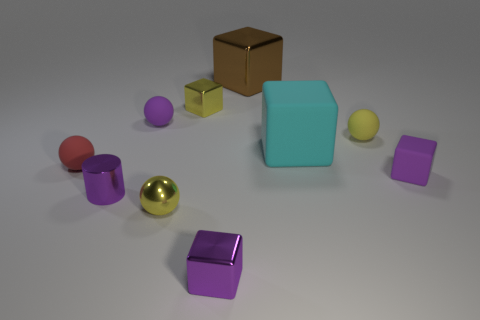There is a yellow ball in front of the purple matte block; does it have the same size as the yellow metal block?
Your response must be concise. Yes. Is the small yellow sphere that is in front of the tiny purple shiny cylinder made of the same material as the purple cube to the left of the brown object?
Give a very brief answer. Yes. Are there any rubber balls that have the same size as the yellow block?
Your answer should be very brief. Yes. What is the shape of the purple metal thing on the left side of the tiny yellow object that is behind the tiny purple matte thing that is on the left side of the brown cube?
Ensure brevity in your answer.  Cylinder. Are there more small cylinders on the left side of the small purple metallic block than tiny green spheres?
Keep it short and to the point. Yes. Is there another tiny rubber object that has the same shape as the cyan matte object?
Offer a very short reply. Yes. Do the big brown thing and the purple block that is on the left side of the tiny rubber cube have the same material?
Offer a very short reply. Yes. What color is the small rubber cube?
Provide a succinct answer. Purple. What number of small purple cubes are to the right of the big thing that is in front of the sphere that is right of the brown cube?
Your answer should be compact. 1. Are there any rubber cubes right of the red matte object?
Your answer should be very brief. Yes. 